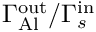Convert formula to latex. <formula><loc_0><loc_0><loc_500><loc_500>\Gamma _ { A l } ^ { o u t } / \Gamma _ { s } ^ { i n }</formula> 